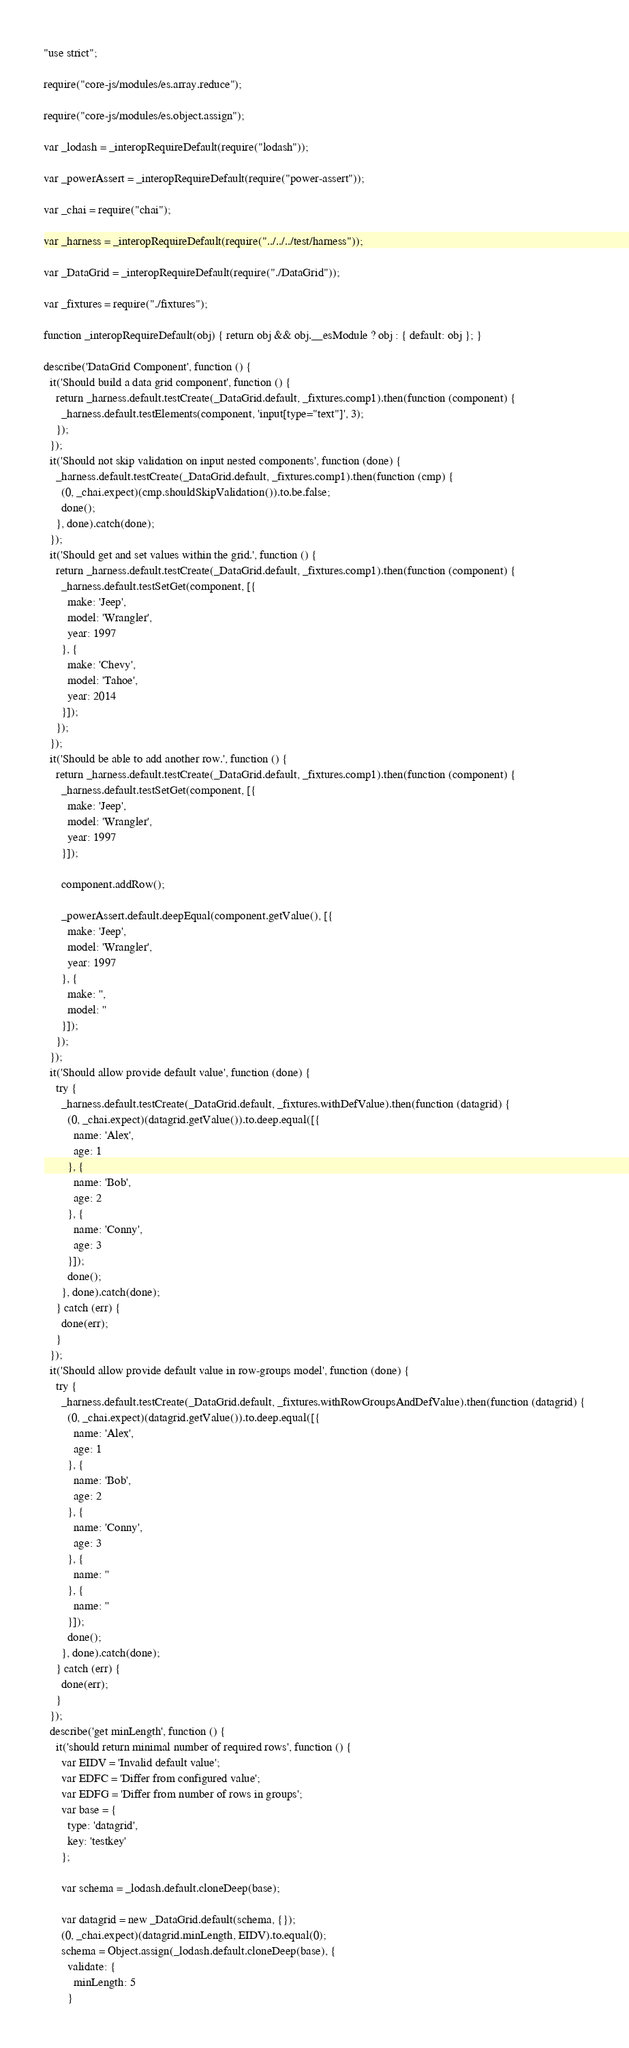<code> <loc_0><loc_0><loc_500><loc_500><_JavaScript_>"use strict";

require("core-js/modules/es.array.reduce");

require("core-js/modules/es.object.assign");

var _lodash = _interopRequireDefault(require("lodash"));

var _powerAssert = _interopRequireDefault(require("power-assert"));

var _chai = require("chai");

var _harness = _interopRequireDefault(require("../../../test/harness"));

var _DataGrid = _interopRequireDefault(require("./DataGrid"));

var _fixtures = require("./fixtures");

function _interopRequireDefault(obj) { return obj && obj.__esModule ? obj : { default: obj }; }

describe('DataGrid Component', function () {
  it('Should build a data grid component', function () {
    return _harness.default.testCreate(_DataGrid.default, _fixtures.comp1).then(function (component) {
      _harness.default.testElements(component, 'input[type="text"]', 3);
    });
  });
  it('Should not skip validation on input nested components', function (done) {
    _harness.default.testCreate(_DataGrid.default, _fixtures.comp1).then(function (cmp) {
      (0, _chai.expect)(cmp.shouldSkipValidation()).to.be.false;
      done();
    }, done).catch(done);
  });
  it('Should get and set values within the grid.', function () {
    return _harness.default.testCreate(_DataGrid.default, _fixtures.comp1).then(function (component) {
      _harness.default.testSetGet(component, [{
        make: 'Jeep',
        model: 'Wrangler',
        year: 1997
      }, {
        make: 'Chevy',
        model: 'Tahoe',
        year: 2014
      }]);
    });
  });
  it('Should be able to add another row.', function () {
    return _harness.default.testCreate(_DataGrid.default, _fixtures.comp1).then(function (component) {
      _harness.default.testSetGet(component, [{
        make: 'Jeep',
        model: 'Wrangler',
        year: 1997
      }]);

      component.addRow();

      _powerAssert.default.deepEqual(component.getValue(), [{
        make: 'Jeep',
        model: 'Wrangler',
        year: 1997
      }, {
        make: '',
        model: ''
      }]);
    });
  });
  it('Should allow provide default value', function (done) {
    try {
      _harness.default.testCreate(_DataGrid.default, _fixtures.withDefValue).then(function (datagrid) {
        (0, _chai.expect)(datagrid.getValue()).to.deep.equal([{
          name: 'Alex',
          age: 1
        }, {
          name: 'Bob',
          age: 2
        }, {
          name: 'Conny',
          age: 3
        }]);
        done();
      }, done).catch(done);
    } catch (err) {
      done(err);
    }
  });
  it('Should allow provide default value in row-groups model', function (done) {
    try {
      _harness.default.testCreate(_DataGrid.default, _fixtures.withRowGroupsAndDefValue).then(function (datagrid) {
        (0, _chai.expect)(datagrid.getValue()).to.deep.equal([{
          name: 'Alex',
          age: 1
        }, {
          name: 'Bob',
          age: 2
        }, {
          name: 'Conny',
          age: 3
        }, {
          name: ''
        }, {
          name: ''
        }]);
        done();
      }, done).catch(done);
    } catch (err) {
      done(err);
    }
  });
  describe('get minLength', function () {
    it('should return minimal number of required rows', function () {
      var EIDV = 'Invalid default value';
      var EDFC = 'Differ from configured value';
      var EDFG = 'Differ from number of rows in groups';
      var base = {
        type: 'datagrid',
        key: 'testkey'
      };

      var schema = _lodash.default.cloneDeep(base);

      var datagrid = new _DataGrid.default(schema, {});
      (0, _chai.expect)(datagrid.minLength, EIDV).to.equal(0);
      schema = Object.assign(_lodash.default.cloneDeep(base), {
        validate: {
          minLength: 5
        }</code> 